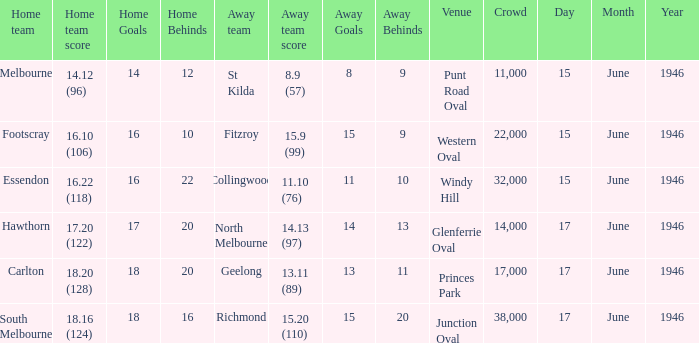Would you be able to parse every entry in this table? {'header': ['Home team', 'Home team score', 'Home Goals', 'Home Behinds', 'Away team', 'Away team score', 'Away Goals', 'Away Behinds', 'Venue', 'Crowd', 'Day', 'Month', 'Year'], 'rows': [['Melbourne', '14.12 (96)', '14', '12', 'St Kilda', '8.9 (57)', '8', '9', 'Punt Road Oval', '11,000', '15', 'June', '1946'], ['Footscray', '16.10 (106)', '16', '10', 'Fitzroy', '15.9 (99)', '15', '9', 'Western Oval', '22,000', '15', 'June', '1946'], ['Essendon', '16.22 (118)', '16', '22', 'Collingwood', '11.10 (76)', '11', '10', 'Windy Hill', '32,000', '15', 'June', '1946'], ['Hawthorn', '17.20 (122)', '17', '20', 'North Melbourne', '14.13 (97)', '14', '13', 'Glenferrie Oval', '14,000', '17', 'June', '1946'], ['Carlton', '18.20 (128)', '18', '20', 'Geelong', '13.11 (89)', '13', '11', 'Princes Park', '17,000', '17', 'June', '1946'], ['South Melbourne', '18.16 (124)', '18', '16', 'Richmond', '15.20 (110)', '15', '20', 'Junction Oval', '38,000', '17', 'June', '1946']]} Which home team has a home team 14.12 (96)? Melbourne. 